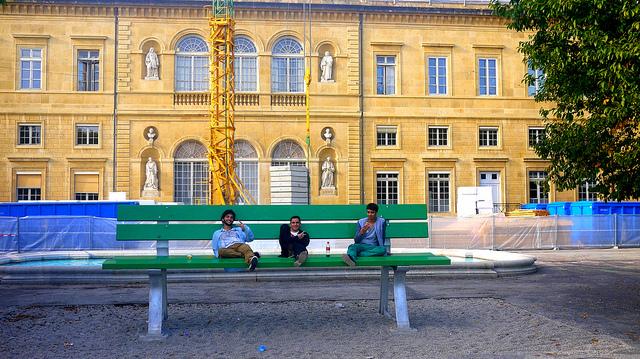Is there construction happening in the scene?
Write a very short answer. Yes. How many men are sitting on the bench?
Keep it brief. 3. What is unusual about the men on the bench?
Keep it brief. Small. 